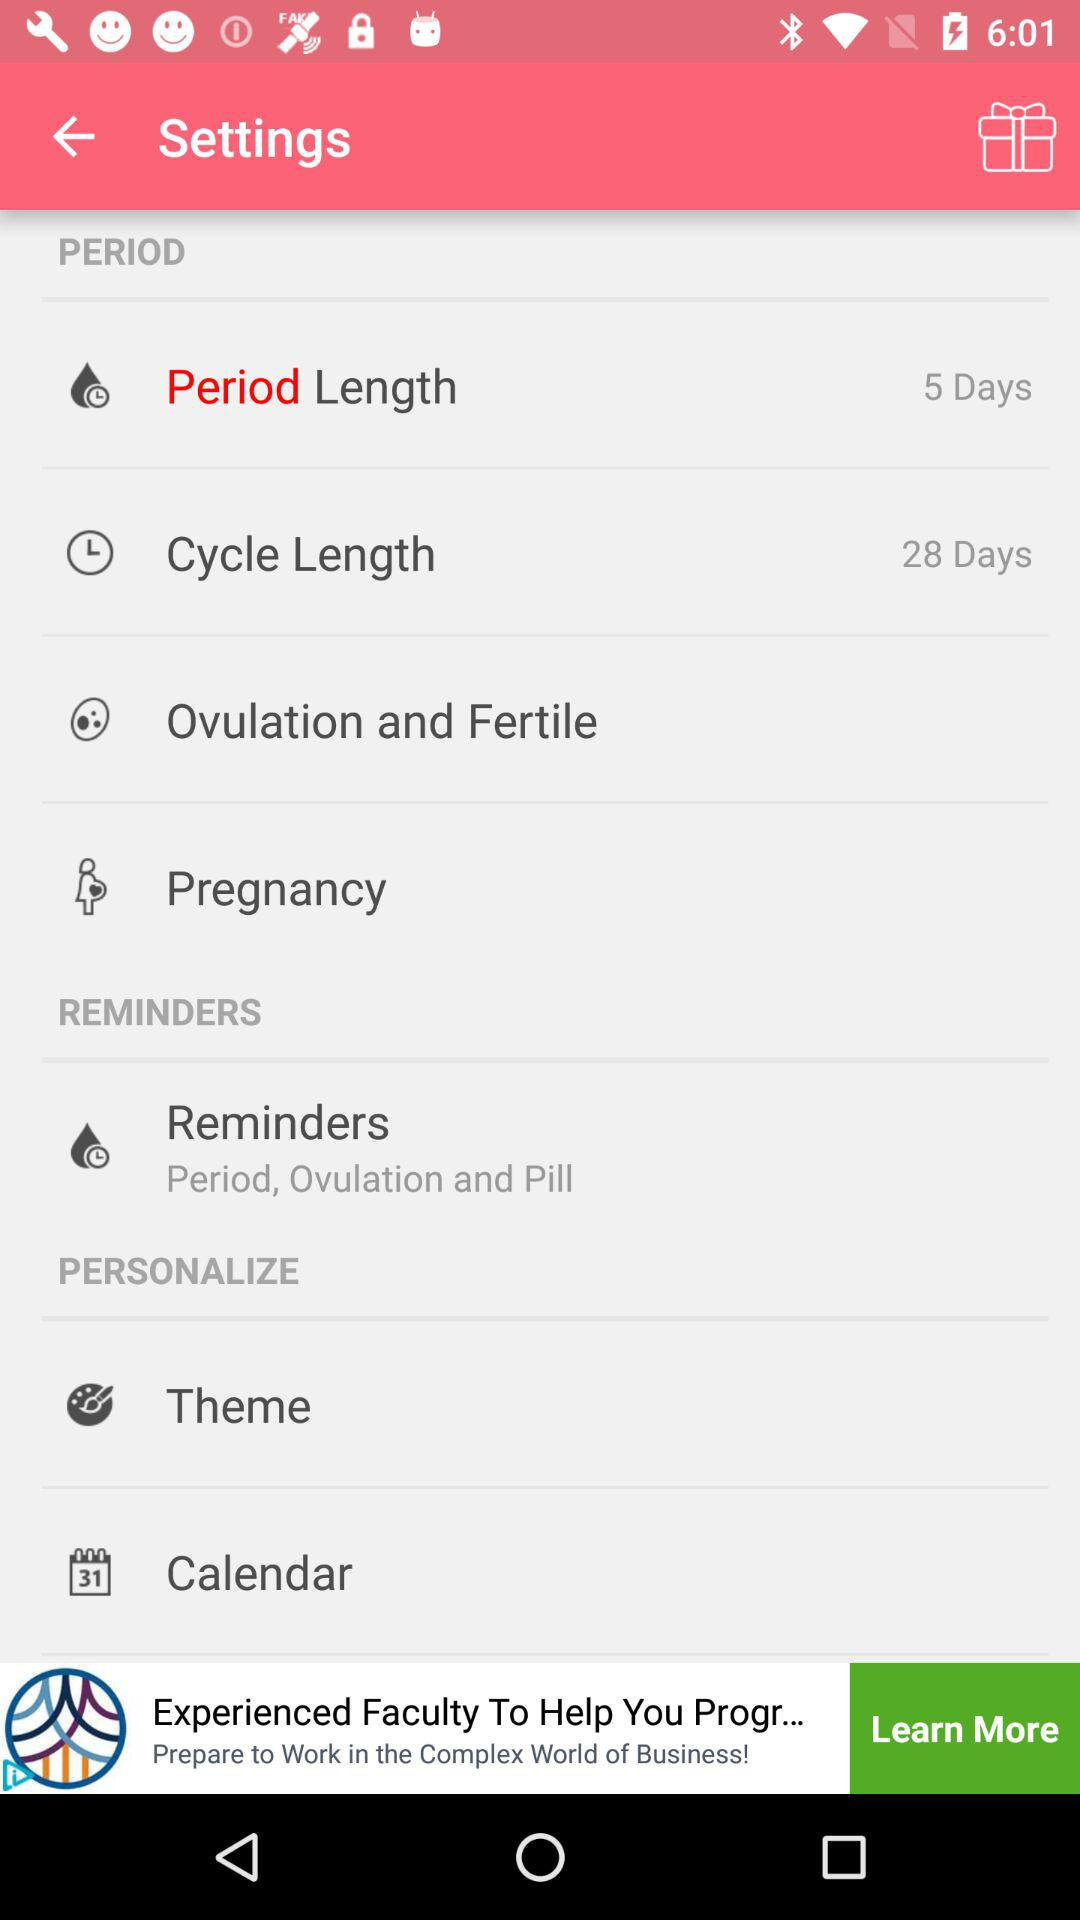What is the period length? The period length is 5 days. 